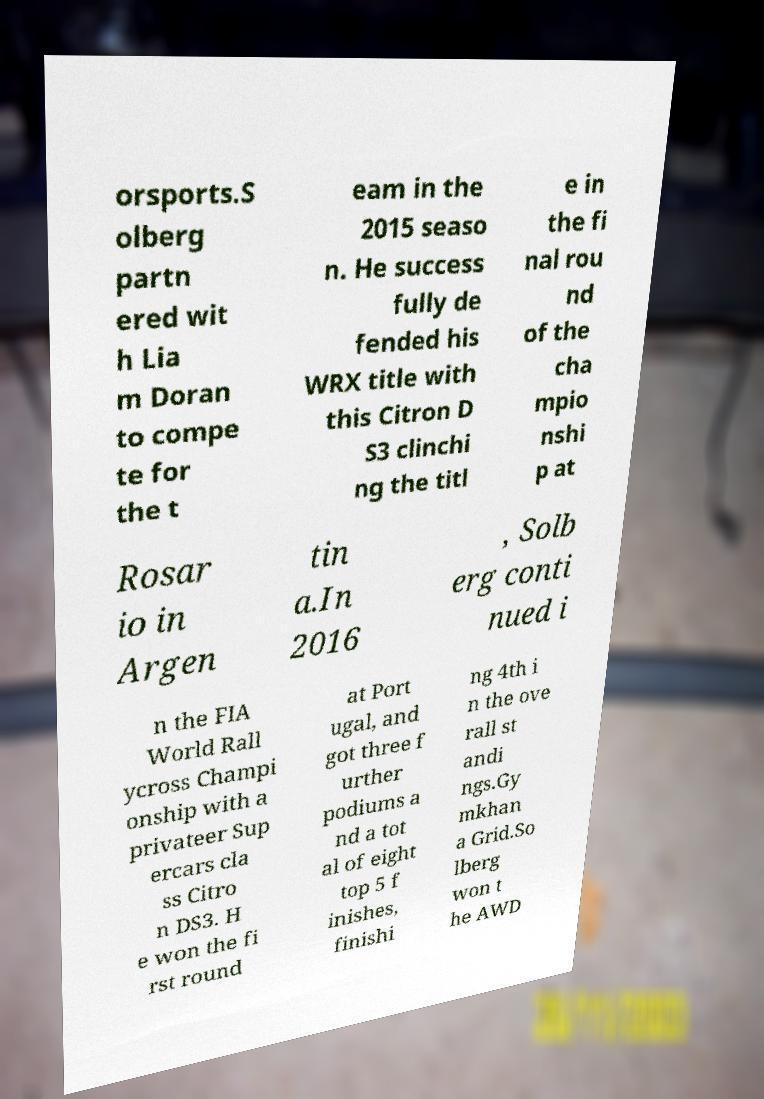I need the written content from this picture converted into text. Can you do that? orsports.S olberg partn ered wit h Lia m Doran to compe te for the t eam in the 2015 seaso n. He success fully de fended his WRX title with this Citron D S3 clinchi ng the titl e in the fi nal rou nd of the cha mpio nshi p at Rosar io in Argen tin a.In 2016 , Solb erg conti nued i n the FIA World Rall ycross Champi onship with a privateer Sup ercars cla ss Citro n DS3. H e won the fi rst round at Port ugal, and got three f urther podiums a nd a tot al of eight top 5 f inishes, finishi ng 4th i n the ove rall st andi ngs.Gy mkhan a Grid.So lberg won t he AWD 